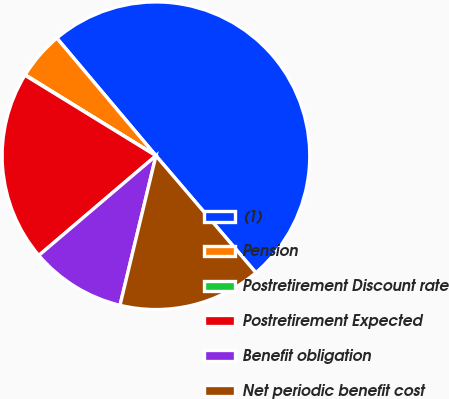Convert chart. <chart><loc_0><loc_0><loc_500><loc_500><pie_chart><fcel>(1)<fcel>Pension<fcel>Postretirement Discount rate<fcel>Postretirement Expected<fcel>Benefit obligation<fcel>Net periodic benefit cost<nl><fcel>49.89%<fcel>5.04%<fcel>0.05%<fcel>19.99%<fcel>10.02%<fcel>15.01%<nl></chart> 